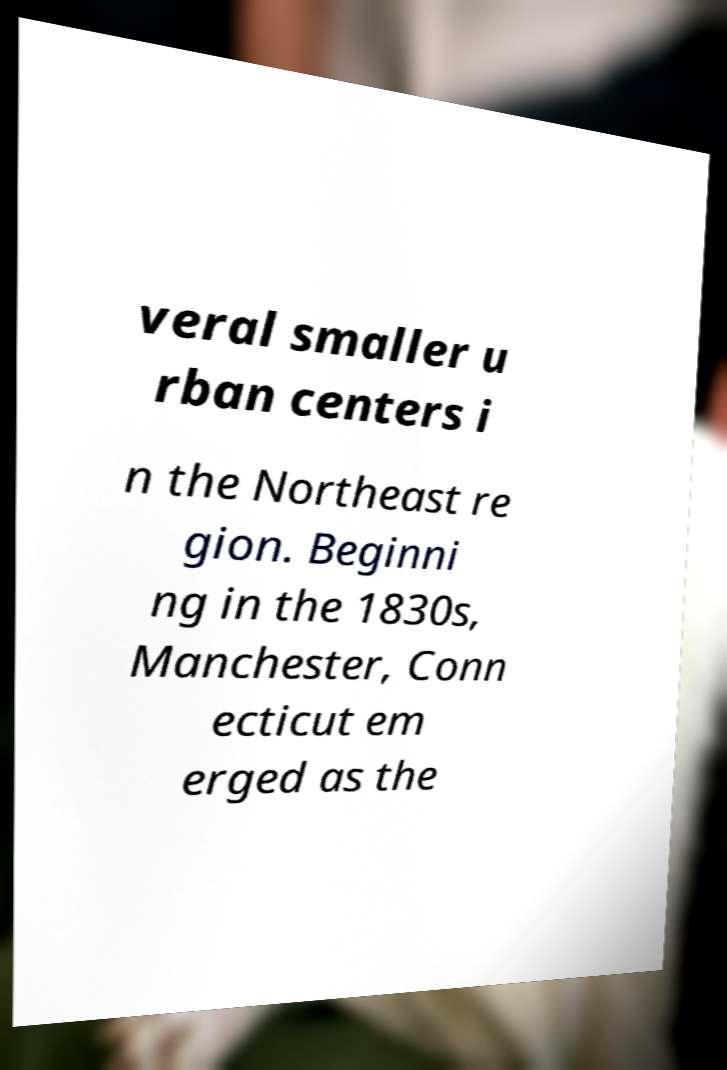Could you assist in decoding the text presented in this image and type it out clearly? veral smaller u rban centers i n the Northeast re gion. Beginni ng in the 1830s, Manchester, Conn ecticut em erged as the 